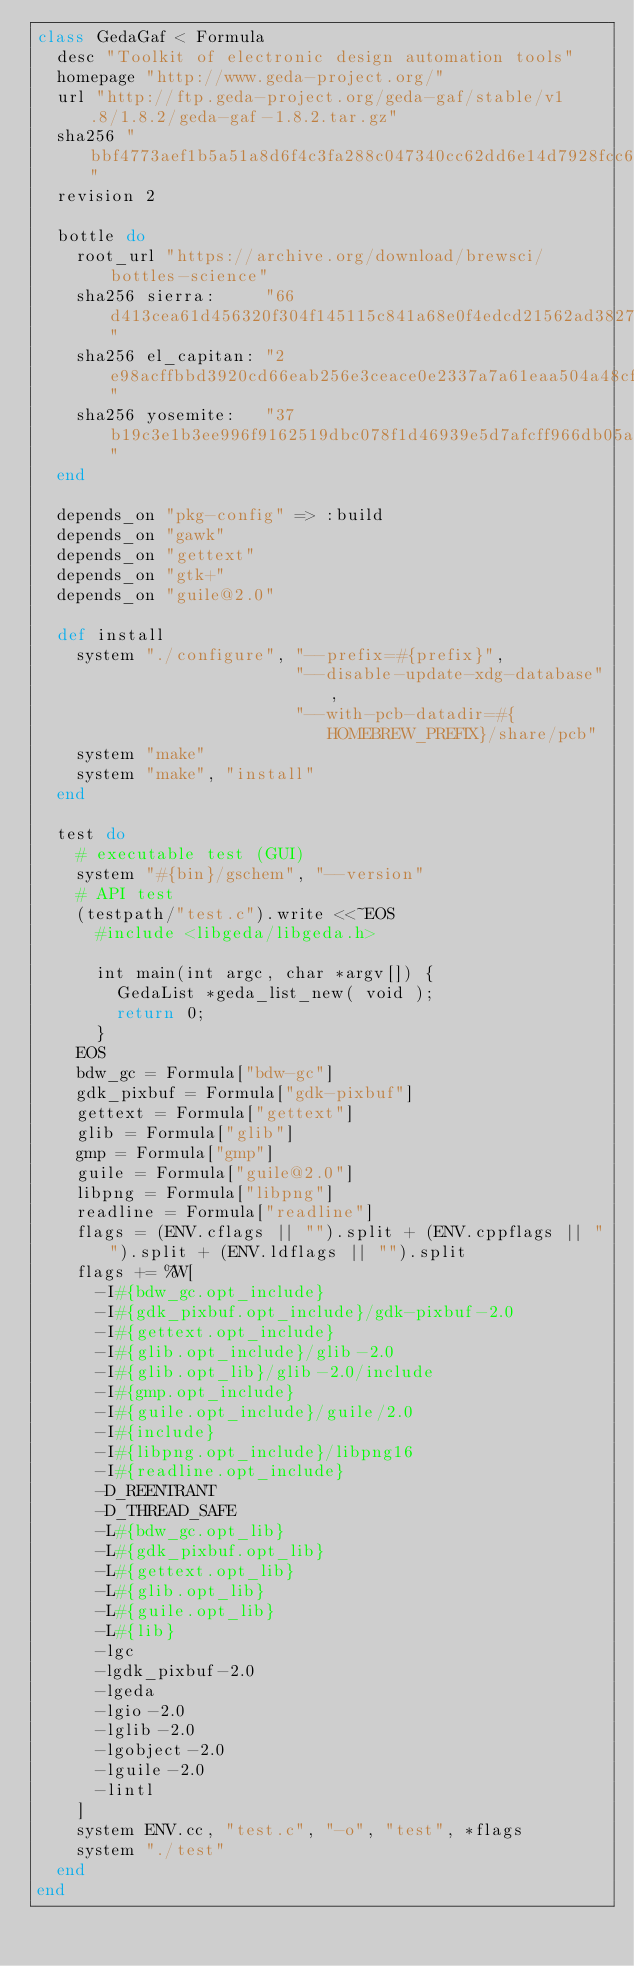<code> <loc_0><loc_0><loc_500><loc_500><_Ruby_>class GedaGaf < Formula
  desc "Toolkit of electronic design automation tools"
  homepage "http://www.geda-project.org/"
  url "http://ftp.geda-project.org/geda-gaf/stable/v1.8/1.8.2/geda-gaf-1.8.2.tar.gz"
  sha256 "bbf4773aef1b5a51a8d6f4c3fa288c047340cc62dd6e14d7928fcc6e4051b721"
  revision 2

  bottle do
    root_url "https://archive.org/download/brewsci/bottles-science"
    sha256 sierra:     "66d413cea61d456320f304f145115c841a68e0f4edcd21562ad3827314121576"
    sha256 el_capitan: "2e98acffbbd3920cd66eab256e3ceace0e2337a7a61eaa504a48cf58e6a206df"
    sha256 yosemite:   "37b19c3e1b3ee996f9162519dbc078f1d46939e5d7afcff966db05a1ba97ab7c"
  end

  depends_on "pkg-config" => :build
  depends_on "gawk"
  depends_on "gettext"
  depends_on "gtk+"
  depends_on "guile@2.0"

  def install
    system "./configure", "--prefix=#{prefix}",
                          "--disable-update-xdg-database",
                          "--with-pcb-datadir=#{HOMEBREW_PREFIX}/share/pcb"
    system "make"
    system "make", "install"
  end

  test do
    # executable test (GUI)
    system "#{bin}/gschem", "--version"
    # API test
    (testpath/"test.c").write <<~EOS
      #include <libgeda/libgeda.h>

      int main(int argc, char *argv[]) {
        GedaList *geda_list_new( void );
        return 0;
      }
    EOS
    bdw_gc = Formula["bdw-gc"]
    gdk_pixbuf = Formula["gdk-pixbuf"]
    gettext = Formula["gettext"]
    glib = Formula["glib"]
    gmp = Formula["gmp"]
    guile = Formula["guile@2.0"]
    libpng = Formula["libpng"]
    readline = Formula["readline"]
    flags = (ENV.cflags || "").split + (ENV.cppflags || "").split + (ENV.ldflags || "").split
    flags += %W[
      -I#{bdw_gc.opt_include}
      -I#{gdk_pixbuf.opt_include}/gdk-pixbuf-2.0
      -I#{gettext.opt_include}
      -I#{glib.opt_include}/glib-2.0
      -I#{glib.opt_lib}/glib-2.0/include
      -I#{gmp.opt_include}
      -I#{guile.opt_include}/guile/2.0
      -I#{include}
      -I#{libpng.opt_include}/libpng16
      -I#{readline.opt_include}
      -D_REENTRANT
      -D_THREAD_SAFE
      -L#{bdw_gc.opt_lib}
      -L#{gdk_pixbuf.opt_lib}
      -L#{gettext.opt_lib}
      -L#{glib.opt_lib}
      -L#{guile.opt_lib}
      -L#{lib}
      -lgc
      -lgdk_pixbuf-2.0
      -lgeda
      -lgio-2.0
      -lglib-2.0
      -lgobject-2.0
      -lguile-2.0
      -lintl
    ]
    system ENV.cc, "test.c", "-o", "test", *flags
    system "./test"
  end
end
</code> 